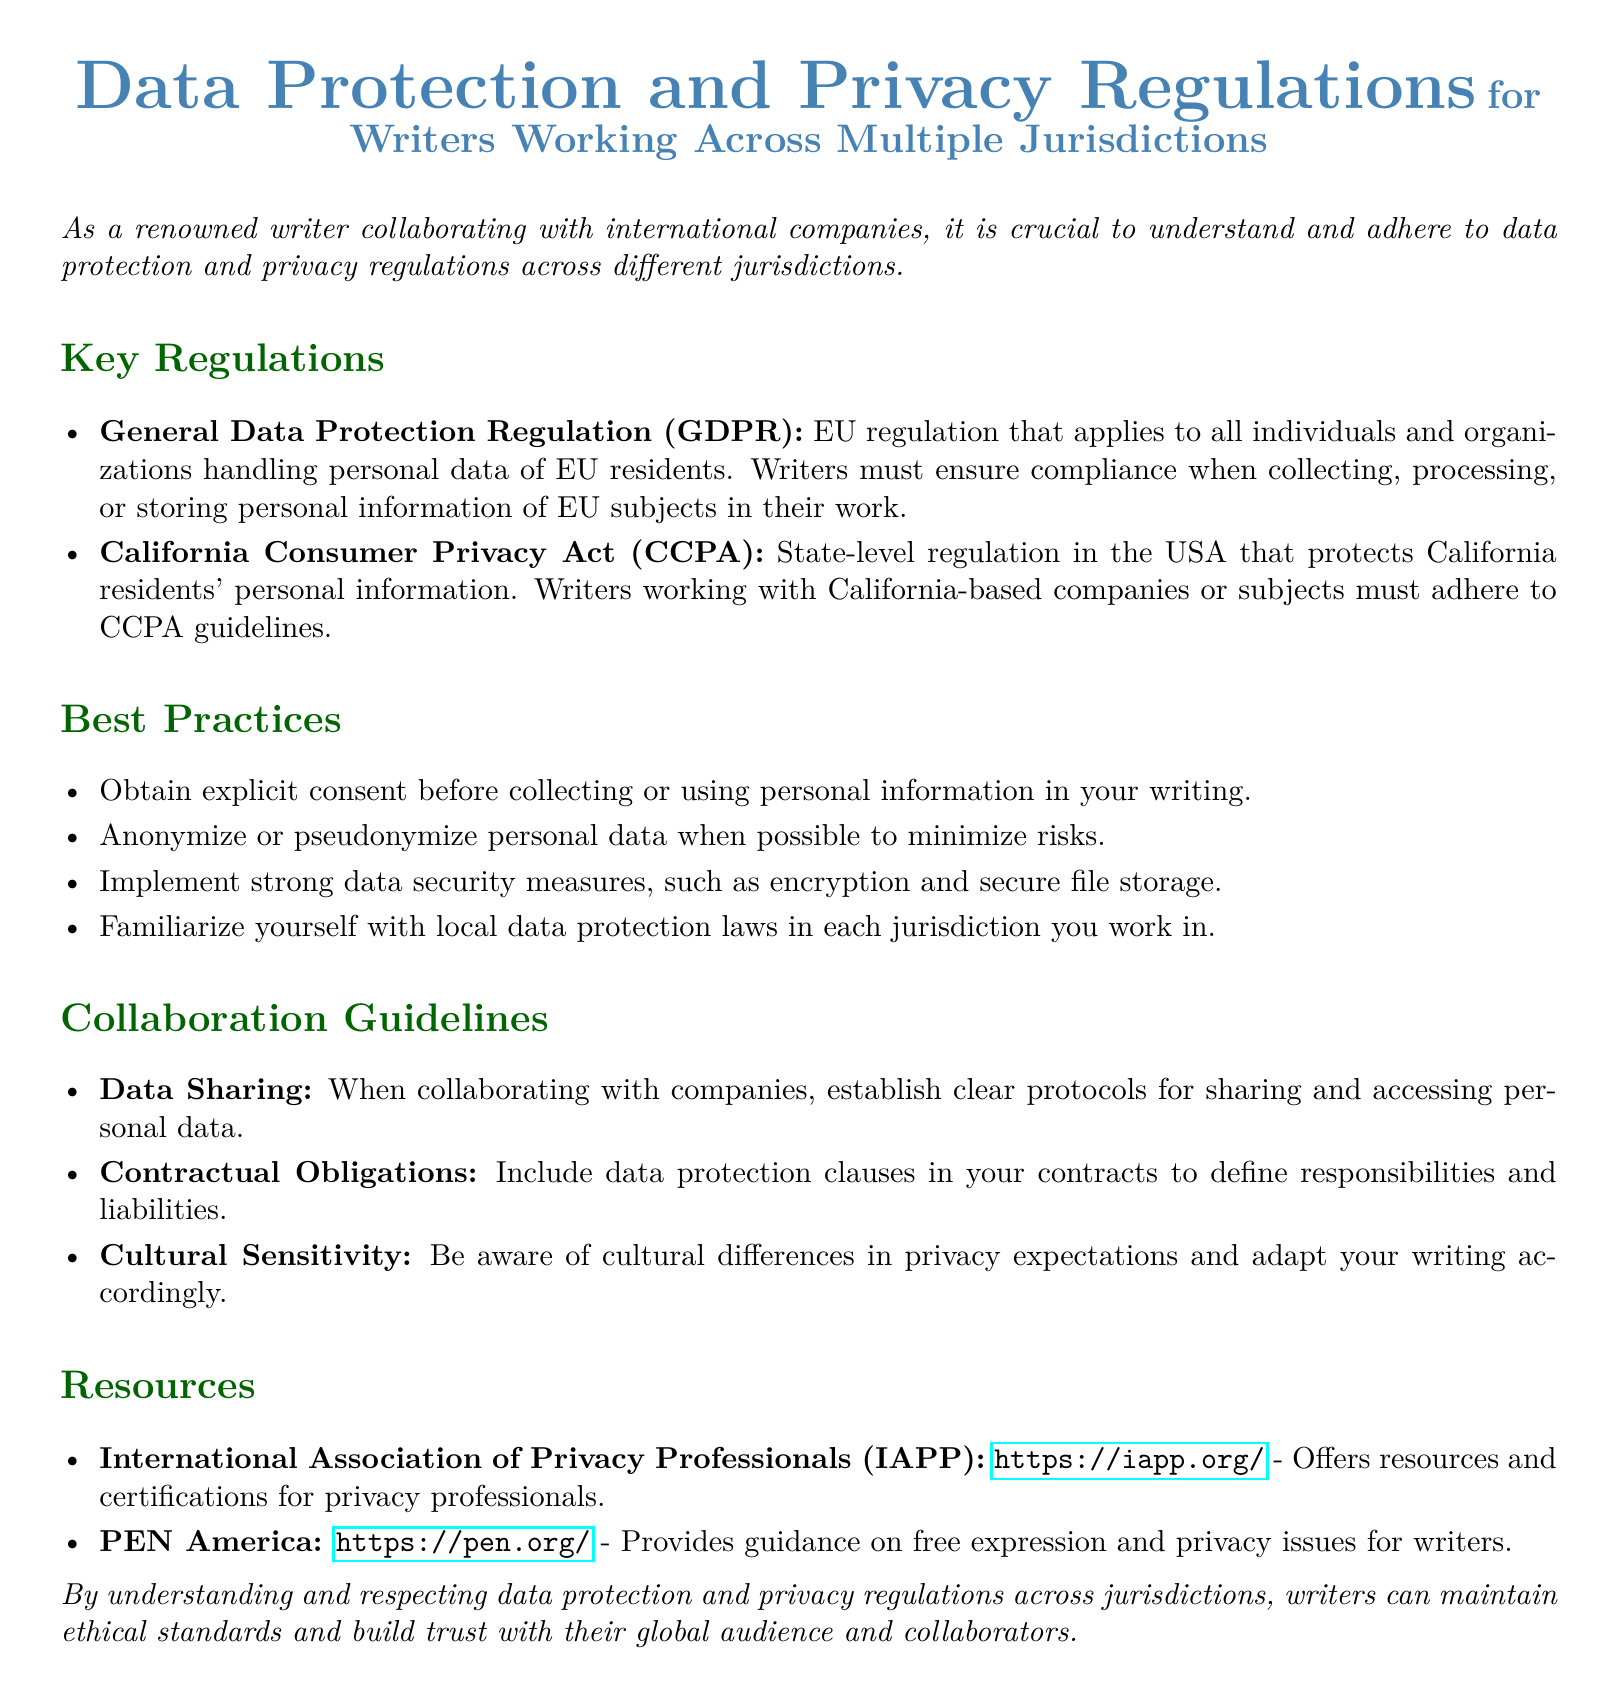What is the title of the document? The title summarizes the main subject of the document, which addresses data protection and privacy regulations for writers.
Answer: Data Protection and Privacy Regulations for Writers Working Across Multiple Jurisdictions What does GDPR stand for? The acronym GDPR represents the General Data Protection Regulation mentioned in the document.
Answer: General Data Protection Regulation Which jurisdiction has the CCPA? The CCPA is identified as a regulation specific to a certain area in the document.
Answer: California What is the main purpose of obtaining explicit consent? The document states that explicit consent must be obtained to ensure compliance with data protection regulations.
Answer: Before collecting or using personal information Name one resource provided for privacy professionals. The document lists organizations that offer resources for data privacy professionals.
Answer: International Association of Privacy Professionals (IAPP) What type of guidelines are provided for collaboration? The document outlines specific guidelines to follow when working with other companies regarding data protection.
Answer: Collaboration Guidelines What two approaches are suggested for handling personal data? The best practices section mentions methods for reducing risks associated with personal data.
Answer: Anonymize or pseudonymize What should contracts include according to the document? The document highlights important aspects of contracts that pertain to data protection responsibilities.
Answer: Data protection clauses 